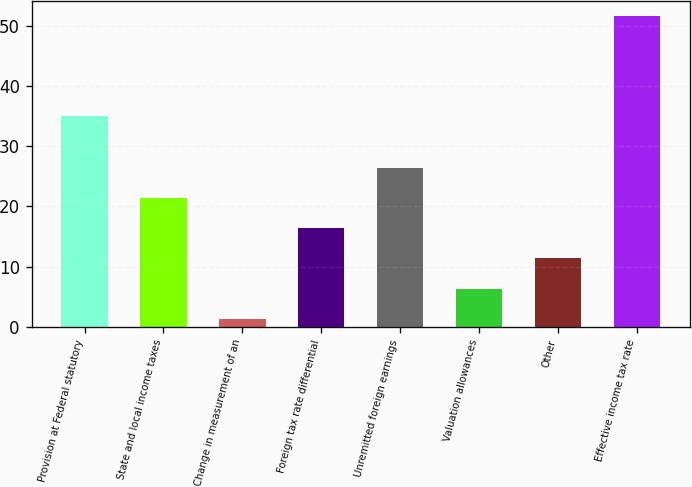Convert chart. <chart><loc_0><loc_0><loc_500><loc_500><bar_chart><fcel>Provision at Federal statutory<fcel>State and local income taxes<fcel>Change in measurement of an<fcel>Foreign tax rate differential<fcel>Unremitted foreign earnings<fcel>Valuation allowances<fcel>Other<fcel>Effective income tax rate<nl><fcel>35<fcel>21.42<fcel>1.3<fcel>16.39<fcel>26.45<fcel>6.33<fcel>11.36<fcel>51.6<nl></chart> 